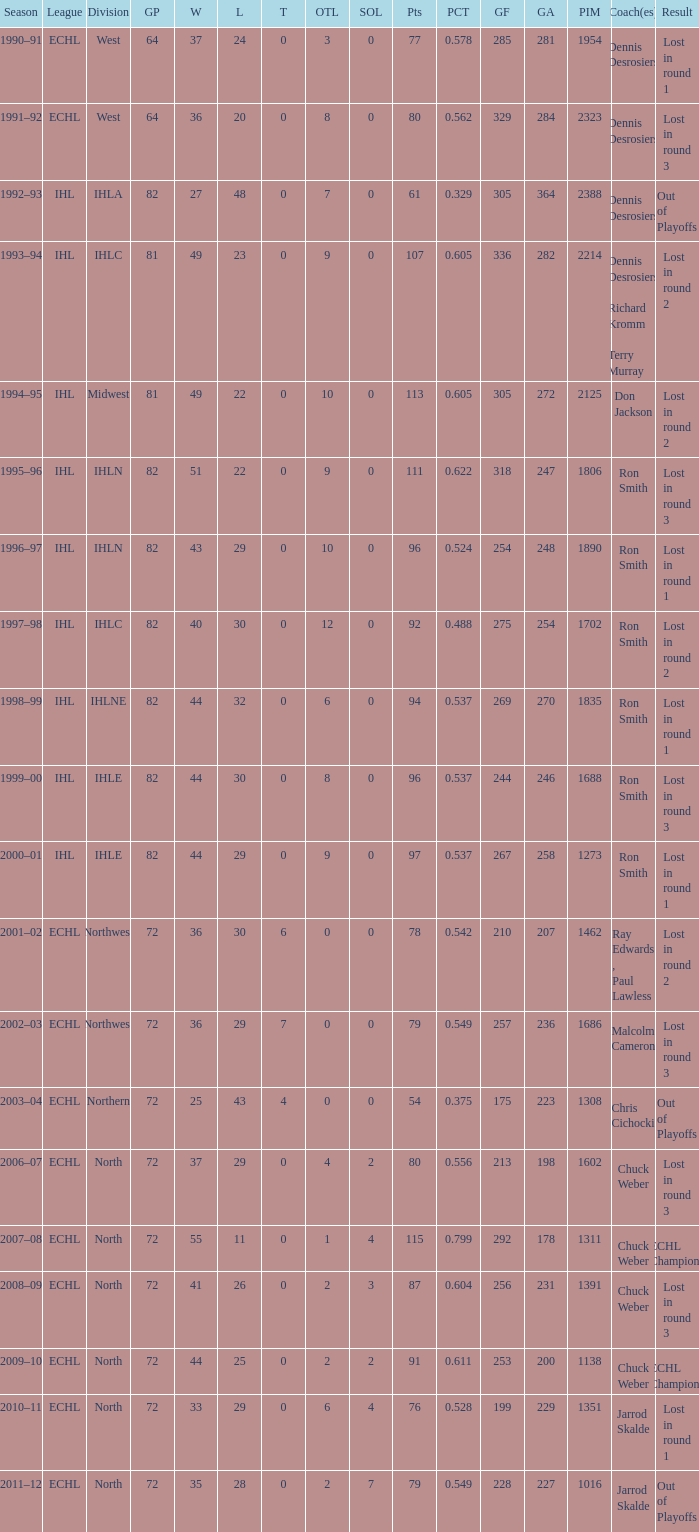What was the maximum OTL if L is 28? 2.0. 